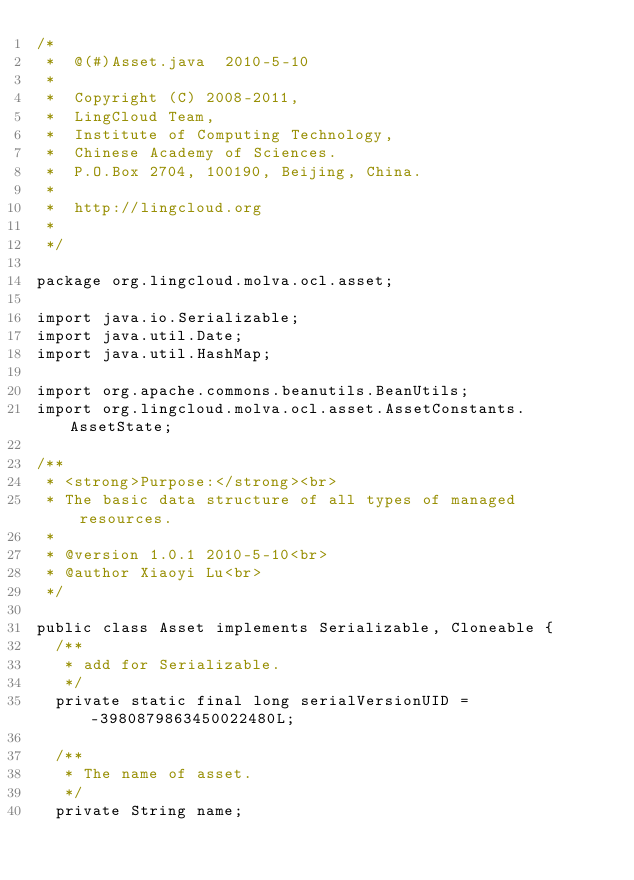<code> <loc_0><loc_0><loc_500><loc_500><_Java_>/*
 *  @(#)Asset.java  2010-5-10
 *
 *  Copyright (C) 2008-2011,
 *  LingCloud Team,
 *  Institute of Computing Technology,
 *  Chinese Academy of Sciences.
 *  P.O.Box 2704, 100190, Beijing, China.
 *
 *  http://lingcloud.org
 *  
 */

package org.lingcloud.molva.ocl.asset;

import java.io.Serializable;
import java.util.Date;
import java.util.HashMap;

import org.apache.commons.beanutils.BeanUtils;
import org.lingcloud.molva.ocl.asset.AssetConstants.AssetState;

/**
 * <strong>Purpose:</strong><br>
 * The basic data structure of all types of managed resources.
 * 
 * @version 1.0.1 2010-5-10<br>
 * @author Xiaoyi Lu<br>
 */

public class Asset implements Serializable, Cloneable {
	/**
	 * add for Serializable.
	 */
	private static final long serialVersionUID = -3980879863450022480L;

	/**
	 * The name of asset.
	 */
	private String name;
</code> 